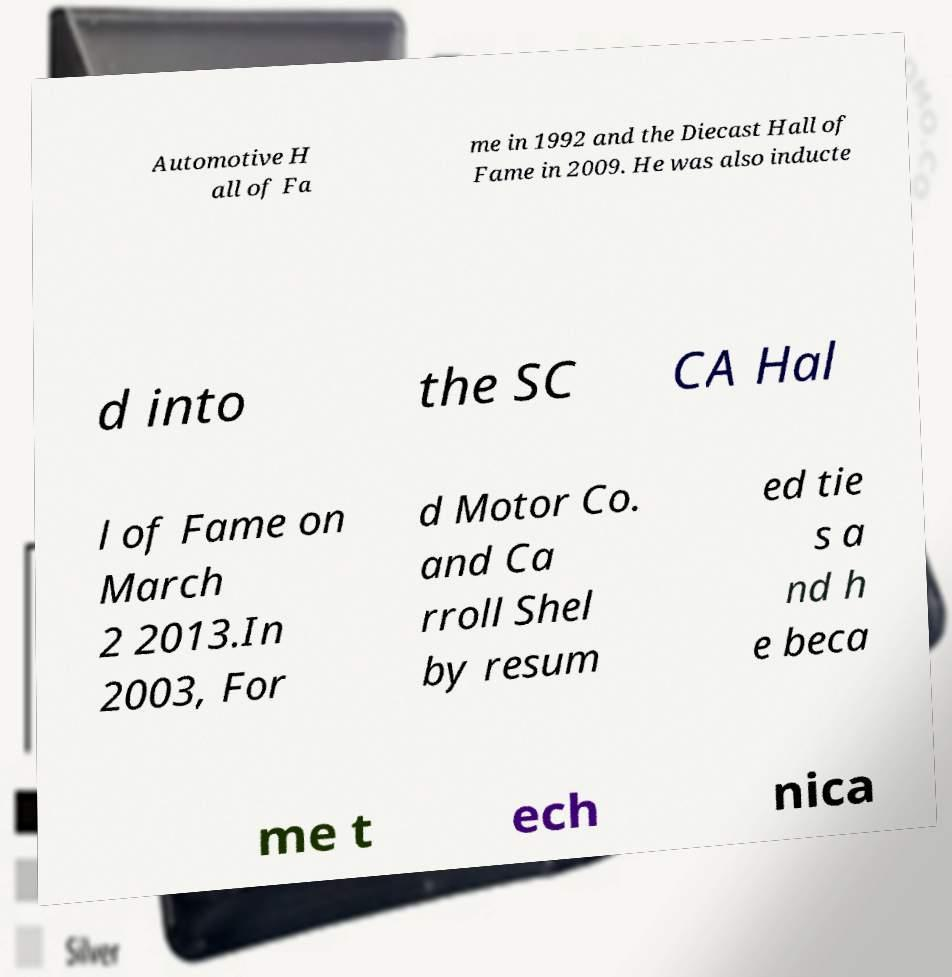There's text embedded in this image that I need extracted. Can you transcribe it verbatim? Automotive H all of Fa me in 1992 and the Diecast Hall of Fame in 2009. He was also inducte d into the SC CA Hal l of Fame on March 2 2013.In 2003, For d Motor Co. and Ca rroll Shel by resum ed tie s a nd h e beca me t ech nica 